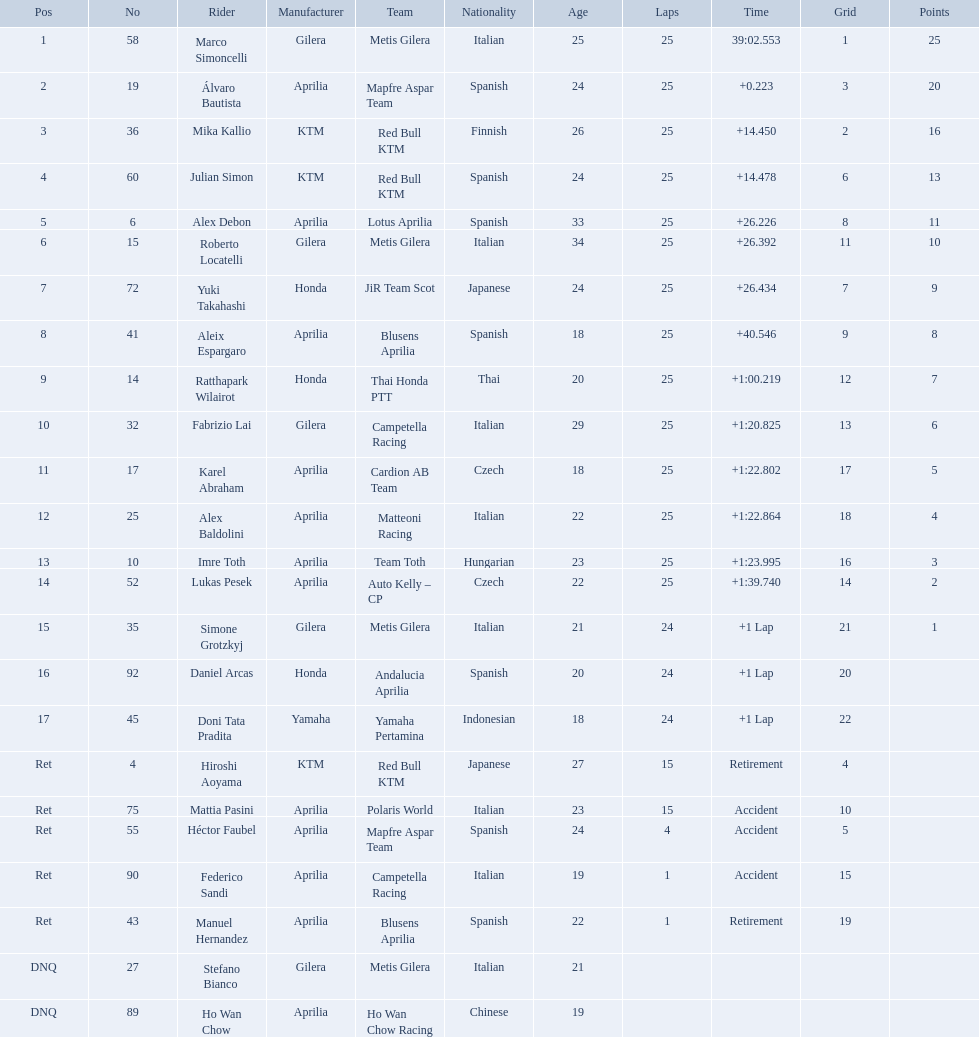How many laps did marco perform? 25. How many laps did hiroshi perform? 15. Which of these numbers are higher? 25. Who swam this number of laps? Marco Simoncelli. How many laps did hiroshi aoyama perform? 15. How many laps did marco simoncelli perform? 25. Who performed more laps out of hiroshi aoyama and marco 
simoncelli? Marco Simoncelli. Who were all of the riders? Marco Simoncelli, Álvaro Bautista, Mika Kallio, Julian Simon, Alex Debon, Roberto Locatelli, Yuki Takahashi, Aleix Espargaro, Ratthapark Wilairot, Fabrizio Lai, Karel Abraham, Alex Baldolini, Imre Toth, Lukas Pesek, Simone Grotzkyj, Daniel Arcas, Doni Tata Pradita, Hiroshi Aoyama, Mattia Pasini, Héctor Faubel, Federico Sandi, Manuel Hernandez, Stefano Bianco, Ho Wan Chow. How many laps did they complete? 25, 25, 25, 25, 25, 25, 25, 25, 25, 25, 25, 25, 25, 25, 24, 24, 24, 15, 15, 4, 1, 1, , . Between marco simoncelli and hiroshi aoyama, who had more laps? Marco Simoncelli. What player number is marked #1 for the australian motorcycle grand prix? 58. Who is the rider that represents the #58 in the australian motorcycle grand prix? Marco Simoncelli. Who are all the riders? Marco Simoncelli, Álvaro Bautista, Mika Kallio, Julian Simon, Alex Debon, Roberto Locatelli, Yuki Takahashi, Aleix Espargaro, Ratthapark Wilairot, Fabrizio Lai, Karel Abraham, Alex Baldolini, Imre Toth, Lukas Pesek, Simone Grotzkyj, Daniel Arcas, Doni Tata Pradita, Hiroshi Aoyama, Mattia Pasini, Héctor Faubel, Federico Sandi, Manuel Hernandez, Stefano Bianco, Ho Wan Chow. Which held rank 1? Marco Simoncelli. 